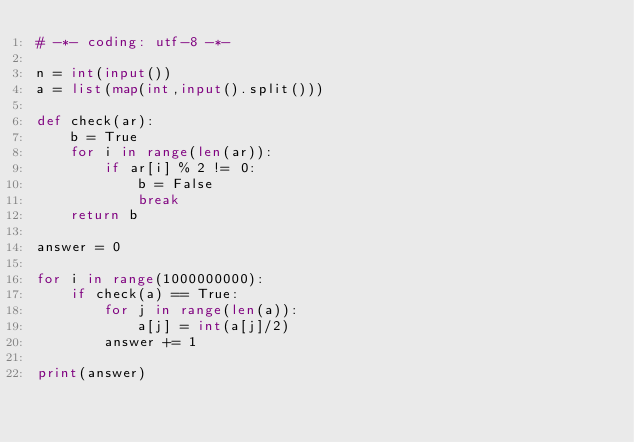<code> <loc_0><loc_0><loc_500><loc_500><_Python_># -*- coding: utf-8 -*-

n = int(input())
a = list(map(int,input().split()))

def check(ar):
    b = True
    for i in range(len(ar)):
        if ar[i] % 2 != 0:
            b = False
            break
    return b

answer = 0

for i in range(1000000000):
    if check(a) == True:
        for j in range(len(a)):
            a[j] = int(a[j]/2)
        answer += 1

print(answer)
</code> 